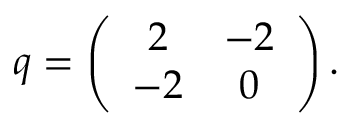<formula> <loc_0><loc_0><loc_500><loc_500>q = \left ( \begin{array} { c c } { 2 } & { - 2 } \\ { - 2 } & { 0 } \end{array} \right ) .</formula> 